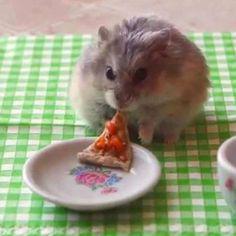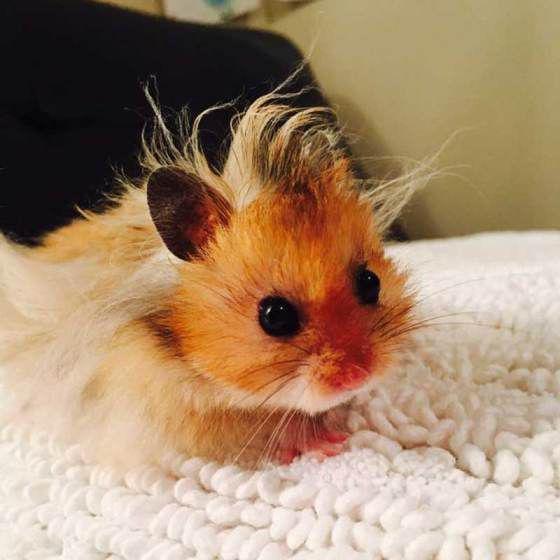The first image is the image on the left, the second image is the image on the right. Evaluate the accuracy of this statement regarding the images: "One image shows a cluster of pets inside something with ears.". Is it true? Answer yes or no. No. The first image is the image on the left, the second image is the image on the right. Analyze the images presented: Is the assertion "There are no more than three rodents" valid? Answer yes or no. Yes. 